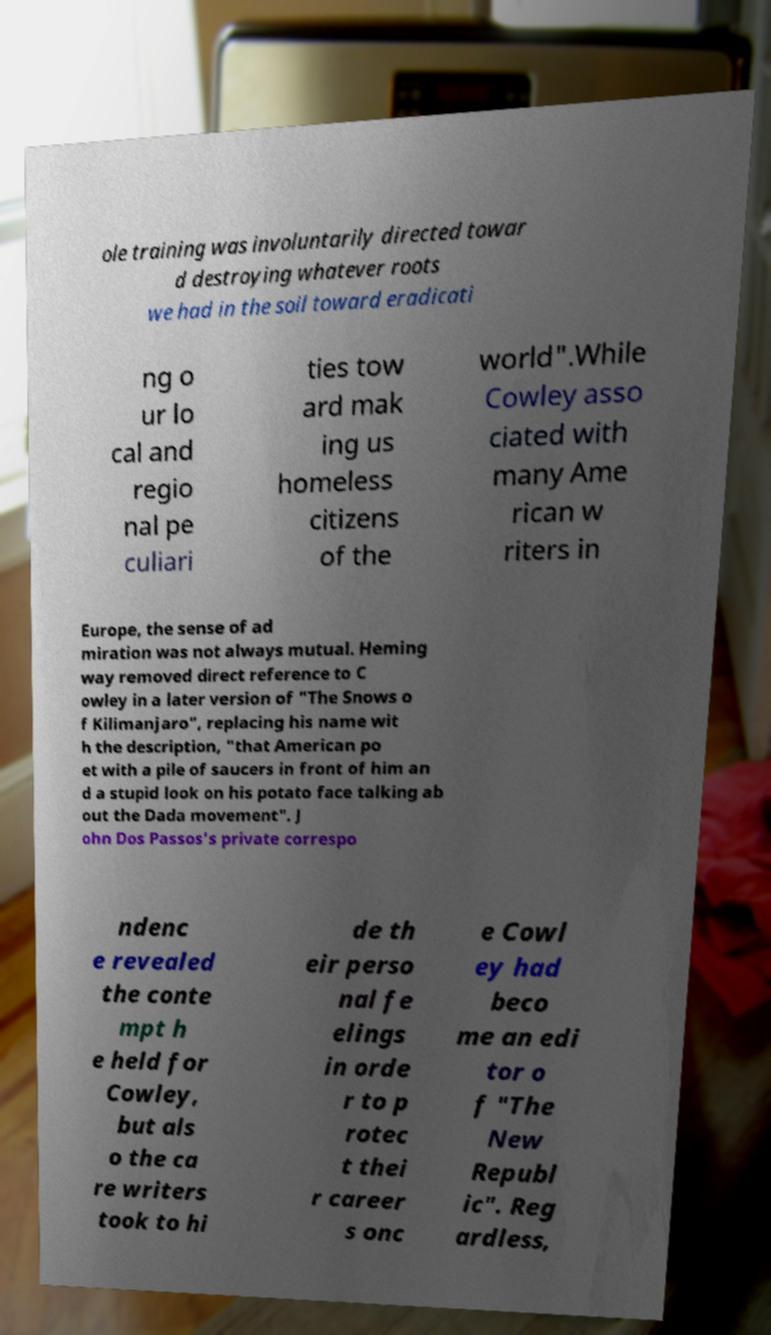There's text embedded in this image that I need extracted. Can you transcribe it verbatim? ole training was involuntarily directed towar d destroying whatever roots we had in the soil toward eradicati ng o ur lo cal and regio nal pe culiari ties tow ard mak ing us homeless citizens of the world".While Cowley asso ciated with many Ame rican w riters in Europe, the sense of ad miration was not always mutual. Heming way removed direct reference to C owley in a later version of "The Snows o f Kilimanjaro", replacing his name wit h the description, "that American po et with a pile of saucers in front of him an d a stupid look on his potato face talking ab out the Dada movement". J ohn Dos Passos's private correspo ndenc e revealed the conte mpt h e held for Cowley, but als o the ca re writers took to hi de th eir perso nal fe elings in orde r to p rotec t thei r career s onc e Cowl ey had beco me an edi tor o f "The New Republ ic". Reg ardless, 